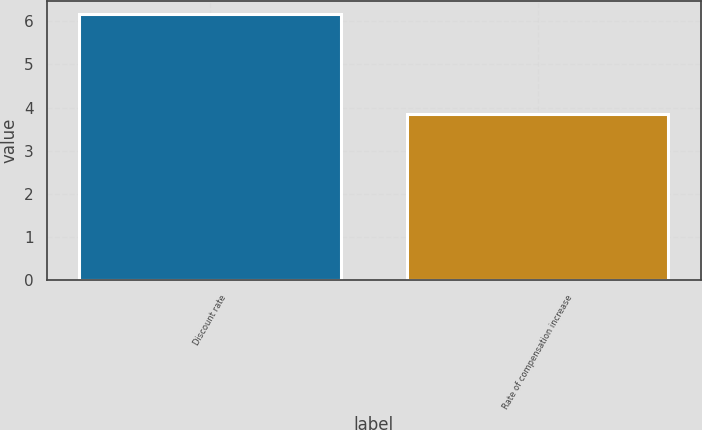Convert chart. <chart><loc_0><loc_0><loc_500><loc_500><bar_chart><fcel>Discount rate<fcel>Rate of compensation increase<nl><fcel>6.16<fcel>3.84<nl></chart> 